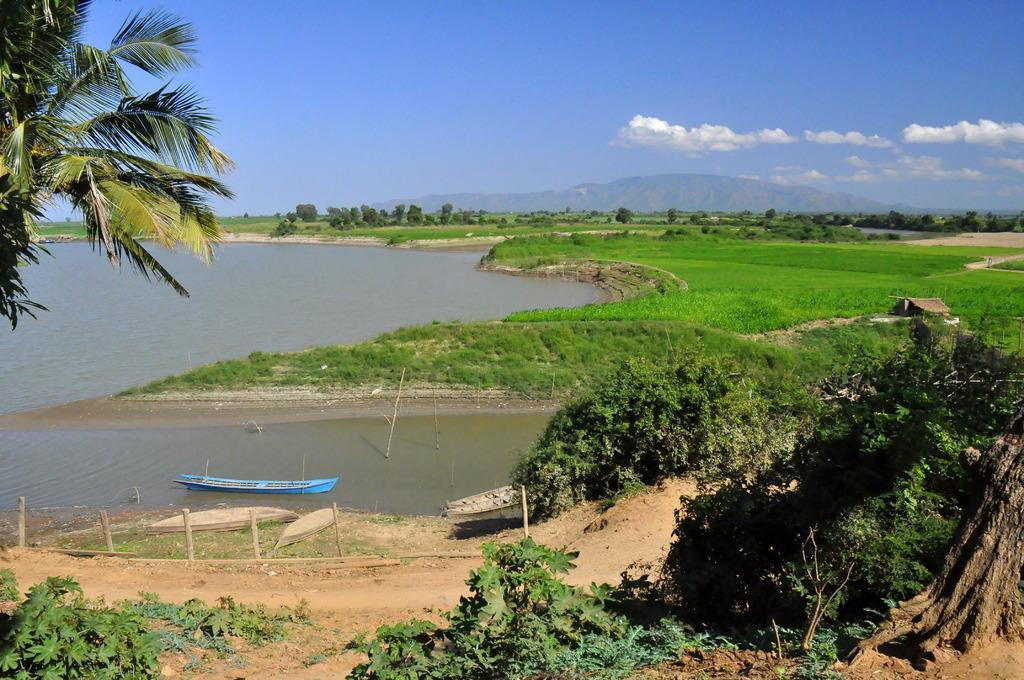How would you summarize this image in a sentence or two? In this picture we can see few trees, boats and water, in the background we can find hills and clouds. 